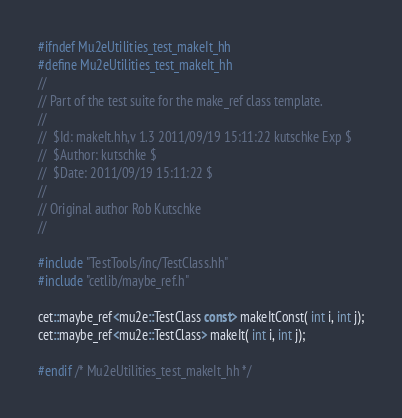<code> <loc_0><loc_0><loc_500><loc_500><_C++_>#ifndef Mu2eUtilities_test_makeIt_hh
#define Mu2eUtilities_test_makeIt_hh
//
// Part of the test suite for the make_ref class template.
//
//  $Id: makeIt.hh,v 1.3 2011/09/19 15:11:22 kutschke Exp $
//  $Author: kutschke $
//  $Date: 2011/09/19 15:11:22 $
//
// Original author Rob Kutschke
//

#include "TestTools/inc/TestClass.hh"
#include "cetlib/maybe_ref.h"

cet::maybe_ref<mu2e::TestClass const> makeItConst( int i, int j);
cet::maybe_ref<mu2e::TestClass> makeIt( int i, int j);

#endif /* Mu2eUtilities_test_makeIt_hh */
</code> 